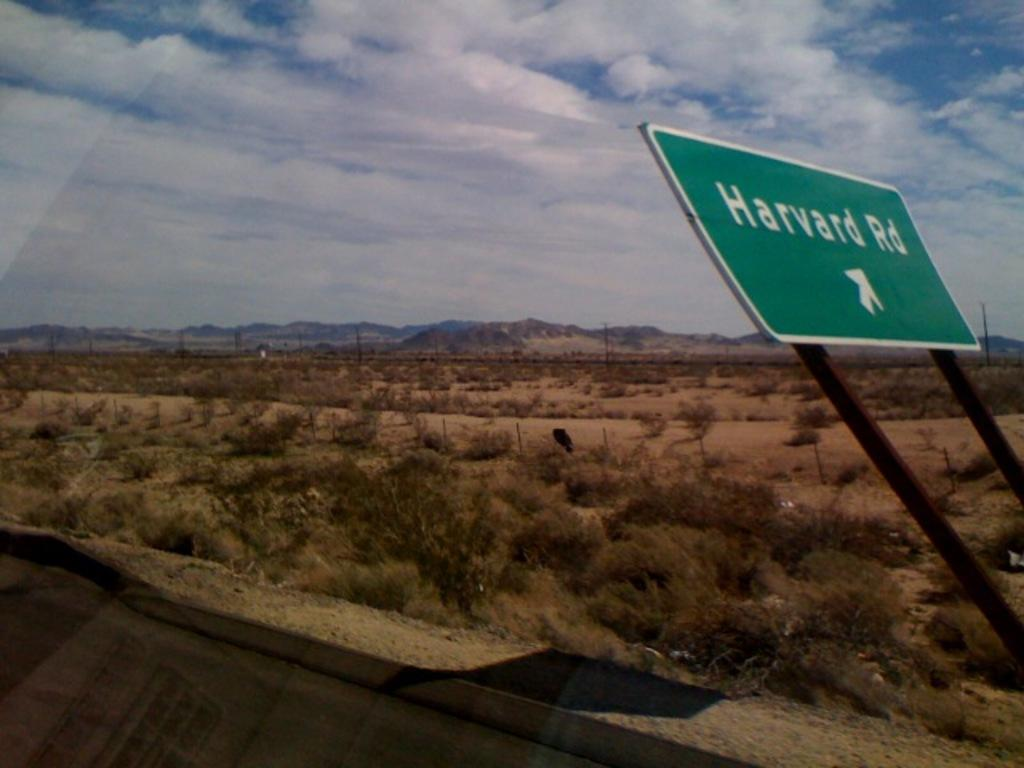<image>
Create a compact narrative representing the image presented. Someone looks out of a vehicle window and you see a Harvard Rd sign that is bent backwards. 